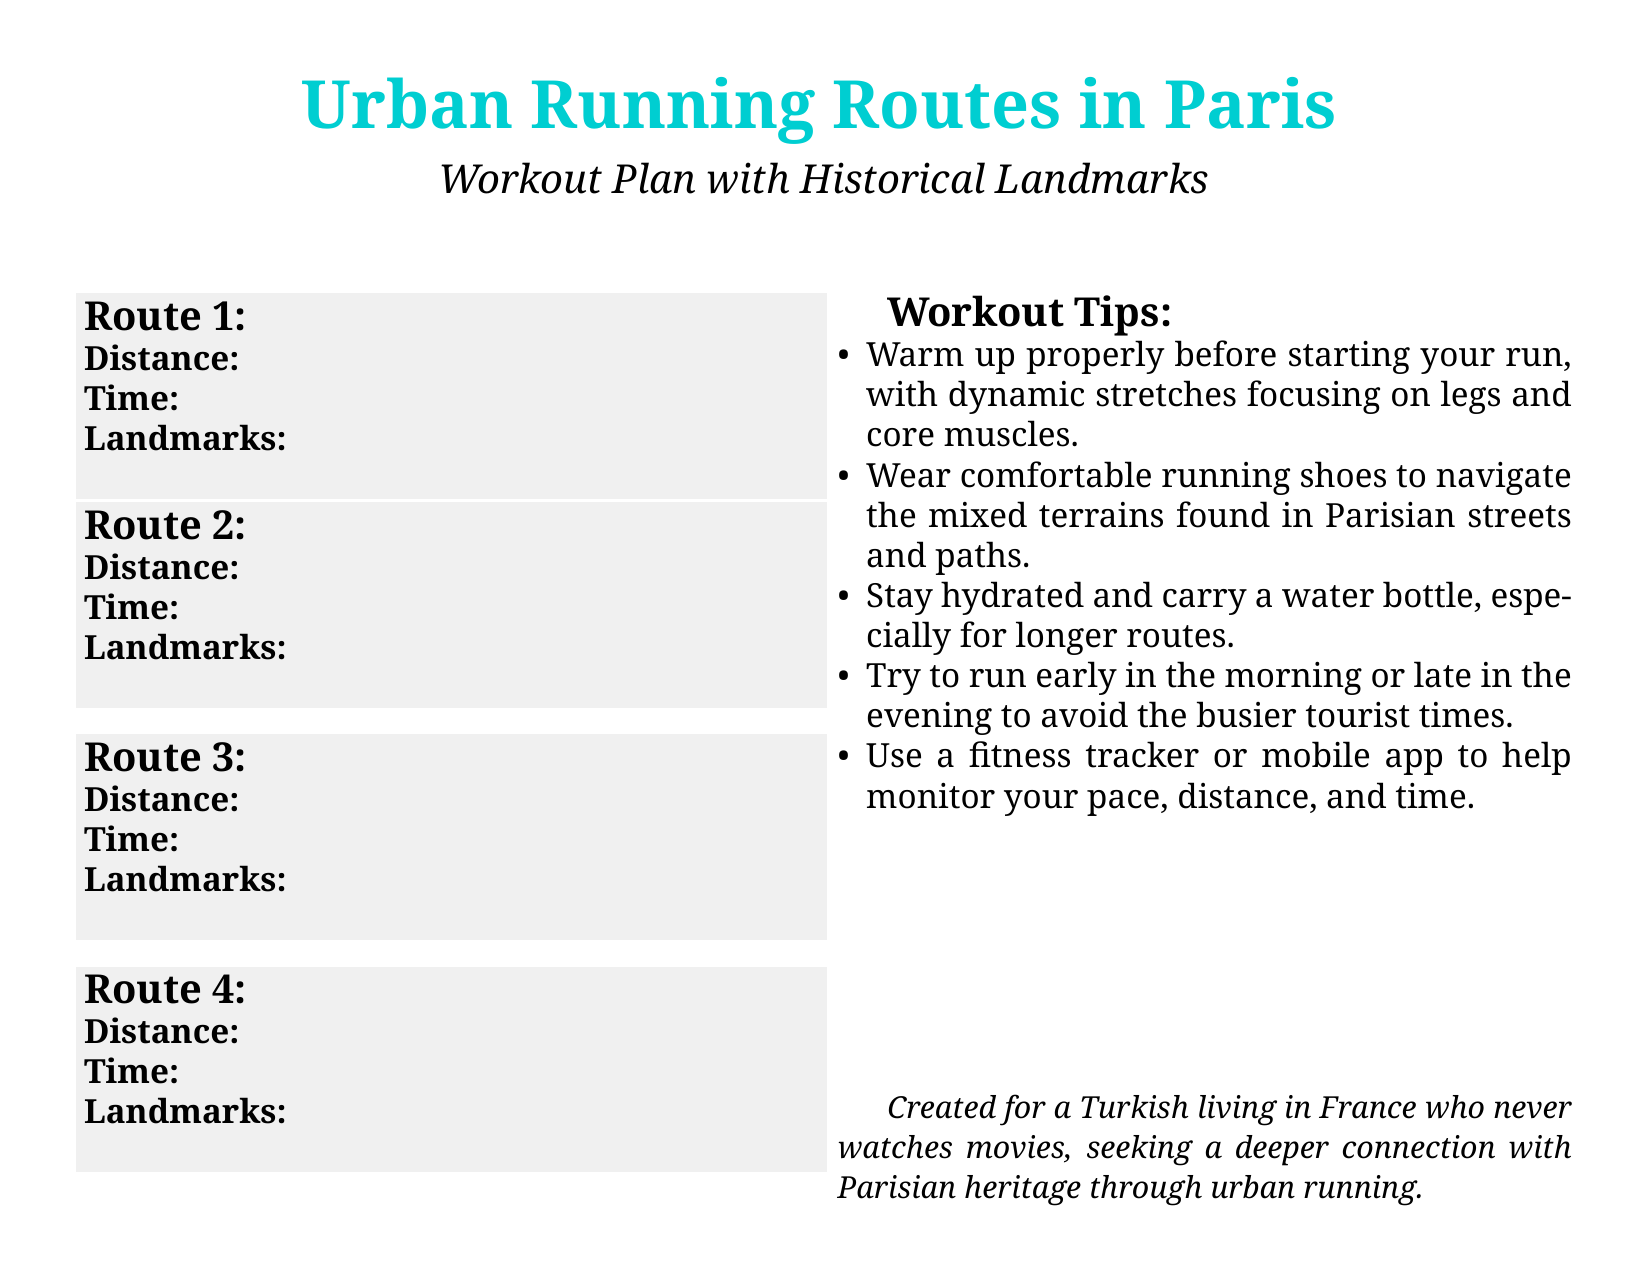What is Route 1? Route 1 is titled "Seine River and Eiffel Tower," as stated in the document.
Answer: Seine River and Eiffel Tower What is the distance of Route 2? The distance of Route 2 is specified as 3 km in the document.
Answer: 3 km How long does it take to complete Route 3? Route 3 takes between 25-35 minutes to complete, according to the document.
Answer: 25-35 minutes Which landmark is associated with Route 4? The document lists multiple landmarks for Route 4, including Sacré-Cœur Basilica.
Answer: Sacré-Cœur Basilica What workout tip is mentioned regarding hydration? The document states that it is important to stay hydrated and carry a water bottle.
Answer: Stay hydrated How many kilometers is Route 1? Route 1 covers a total distance of 5 km, explicitly mentioned in the document.
Answer: 5 km What is the starting point of Route 2? The starting point of Route 2 is the Louvre Pyramid, as per the document details.
Answer: Louvre Pyramid What type of workout plan is this document about? The document focuses on urban running routes that include historical landmarks.
Answer: Urban running routes 